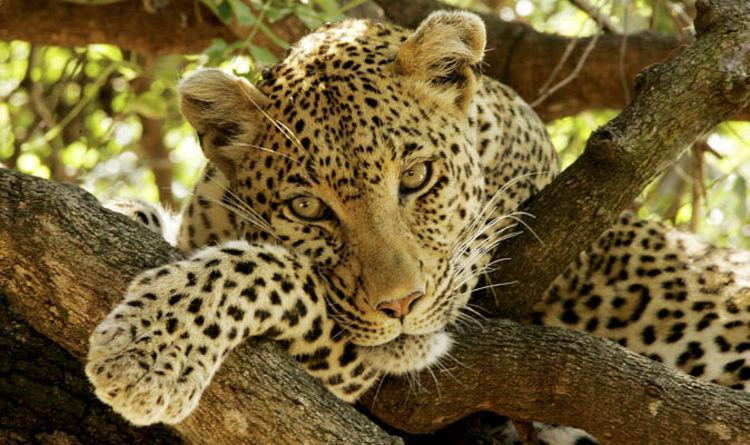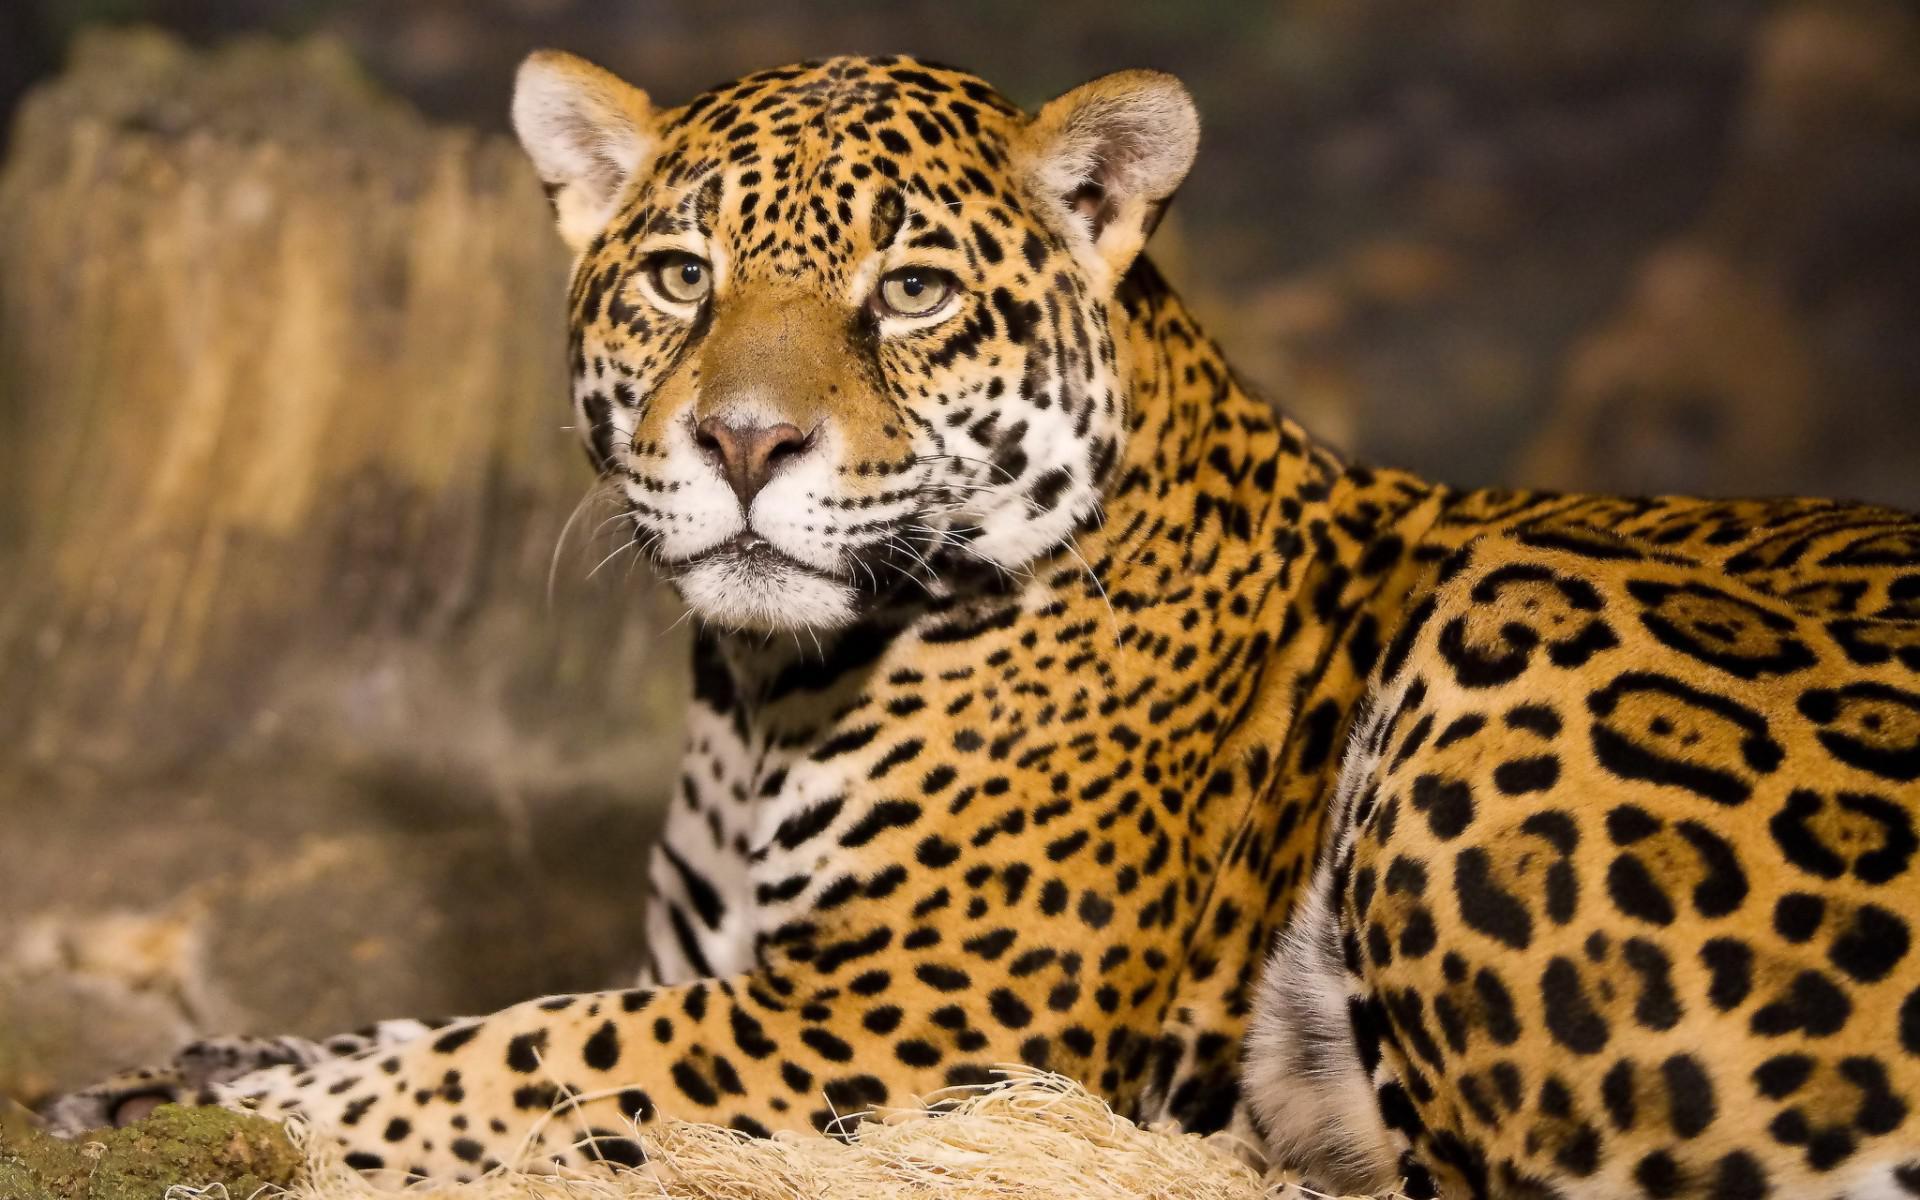The first image is the image on the left, the second image is the image on the right. Given the left and right images, does the statement "The left image contains exactly two cheetahs." hold true? Answer yes or no. No. The first image is the image on the left, the second image is the image on the right. Assess this claim about the two images: "The right image contains half as many cheetahs as the left image.". Correct or not? Answer yes or no. No. 